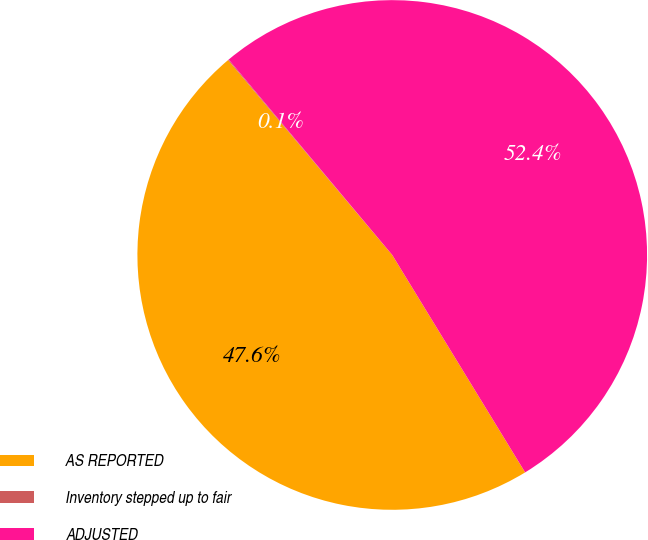Convert chart. <chart><loc_0><loc_0><loc_500><loc_500><pie_chart><fcel>AS REPORTED<fcel>Inventory stepped up to fair<fcel>ADJUSTED<nl><fcel>47.59%<fcel>0.05%<fcel>52.36%<nl></chart> 